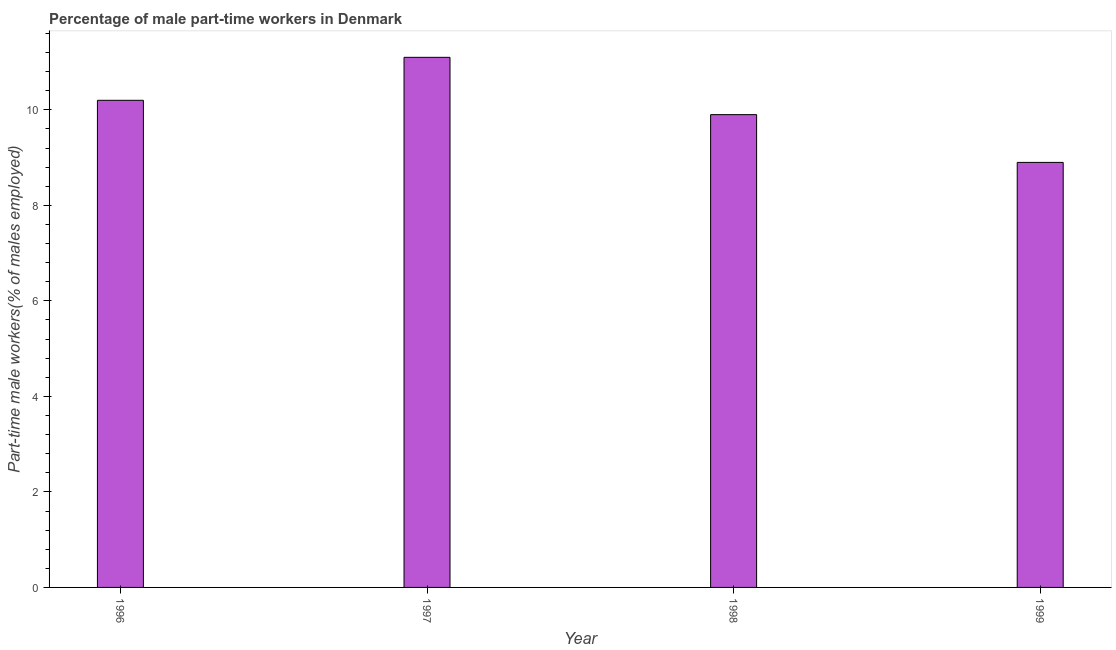Does the graph contain any zero values?
Provide a short and direct response. No. Does the graph contain grids?
Make the answer very short. No. What is the title of the graph?
Your response must be concise. Percentage of male part-time workers in Denmark. What is the label or title of the Y-axis?
Offer a terse response. Part-time male workers(% of males employed). What is the percentage of part-time male workers in 1997?
Offer a very short reply. 11.1. Across all years, what is the maximum percentage of part-time male workers?
Your response must be concise. 11.1. Across all years, what is the minimum percentage of part-time male workers?
Give a very brief answer. 8.9. In which year was the percentage of part-time male workers maximum?
Offer a very short reply. 1997. In which year was the percentage of part-time male workers minimum?
Keep it short and to the point. 1999. What is the sum of the percentage of part-time male workers?
Make the answer very short. 40.1. What is the difference between the percentage of part-time male workers in 1996 and 1997?
Provide a succinct answer. -0.9. What is the average percentage of part-time male workers per year?
Offer a terse response. 10.03. What is the median percentage of part-time male workers?
Make the answer very short. 10.05. In how many years, is the percentage of part-time male workers greater than 4.8 %?
Make the answer very short. 4. Do a majority of the years between 1999 and 1997 (inclusive) have percentage of part-time male workers greater than 0.4 %?
Offer a terse response. Yes. What is the ratio of the percentage of part-time male workers in 1997 to that in 1999?
Give a very brief answer. 1.25. Is the percentage of part-time male workers in 1996 less than that in 1999?
Keep it short and to the point. No. Is the difference between the percentage of part-time male workers in 1997 and 1998 greater than the difference between any two years?
Make the answer very short. No. What is the difference between the highest and the lowest percentage of part-time male workers?
Ensure brevity in your answer.  2.2. Are all the bars in the graph horizontal?
Offer a terse response. No. Are the values on the major ticks of Y-axis written in scientific E-notation?
Provide a short and direct response. No. What is the Part-time male workers(% of males employed) in 1996?
Give a very brief answer. 10.2. What is the Part-time male workers(% of males employed) of 1997?
Your answer should be compact. 11.1. What is the Part-time male workers(% of males employed) in 1998?
Give a very brief answer. 9.9. What is the Part-time male workers(% of males employed) in 1999?
Ensure brevity in your answer.  8.9. What is the difference between the Part-time male workers(% of males employed) in 1996 and 1999?
Make the answer very short. 1.3. What is the difference between the Part-time male workers(% of males employed) in 1997 and 1999?
Provide a short and direct response. 2.2. What is the ratio of the Part-time male workers(% of males employed) in 1996 to that in 1997?
Keep it short and to the point. 0.92. What is the ratio of the Part-time male workers(% of males employed) in 1996 to that in 1998?
Provide a succinct answer. 1.03. What is the ratio of the Part-time male workers(% of males employed) in 1996 to that in 1999?
Make the answer very short. 1.15. What is the ratio of the Part-time male workers(% of males employed) in 1997 to that in 1998?
Offer a very short reply. 1.12. What is the ratio of the Part-time male workers(% of males employed) in 1997 to that in 1999?
Provide a short and direct response. 1.25. What is the ratio of the Part-time male workers(% of males employed) in 1998 to that in 1999?
Your response must be concise. 1.11. 